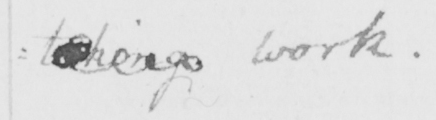Please transcribe the handwritten text in this image. : taking work . 